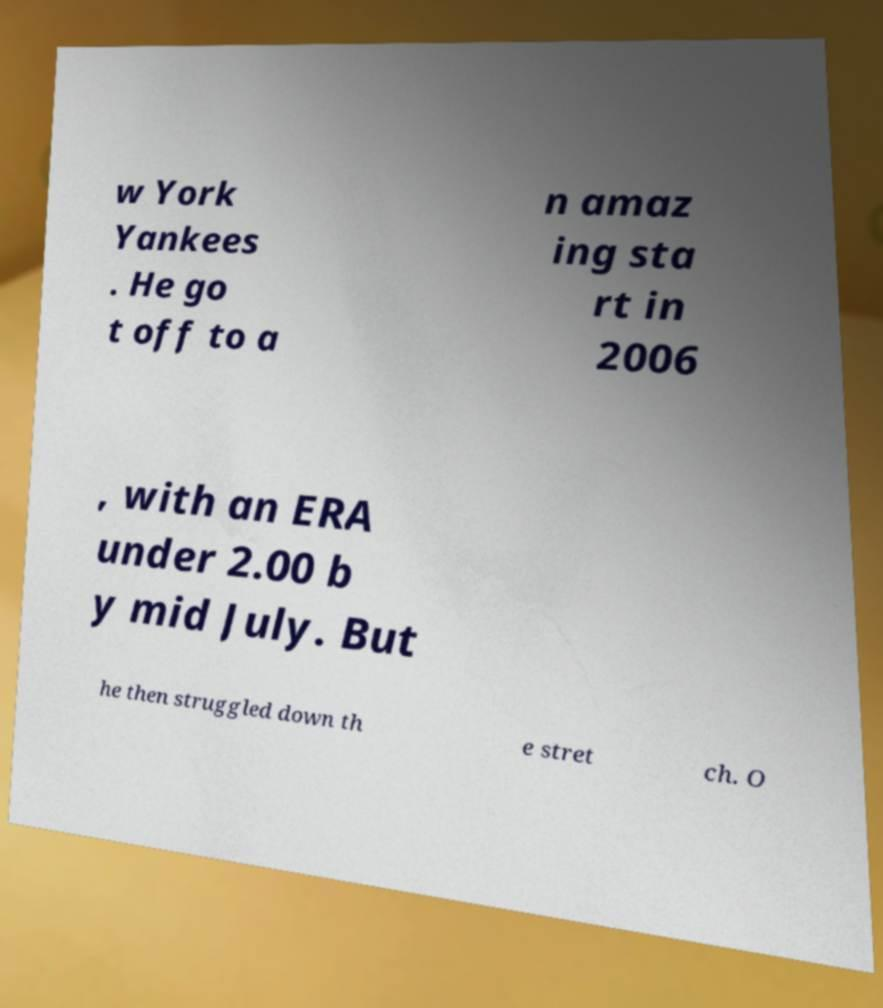I need the written content from this picture converted into text. Can you do that? w York Yankees . He go t off to a n amaz ing sta rt in 2006 , with an ERA under 2.00 b y mid July. But he then struggled down th e stret ch. O 